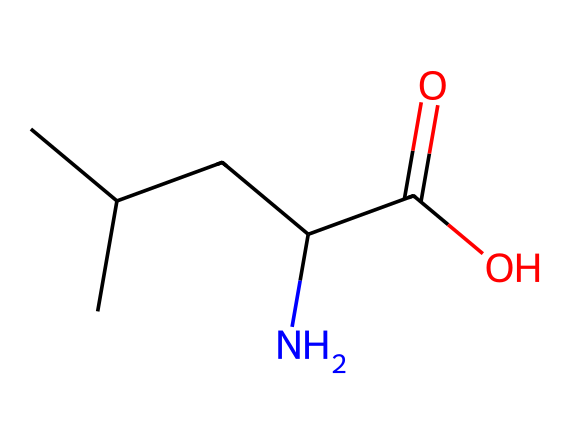What is the name of this chemical? The provided SMILES represents a chemical with the basic structure resembling an amino acid, specifically showing a carboxylic acid functional group and an amine group. This aligns with the characteristics of the amino acid "valine."
Answer: valine How many carbon atoms are present in this molecule? By analyzing the SMILES representation, we can count the number of carbon atoms (C): there are four carbon atoms in the branched structure plus one in the carboxylic group, totaling five carbon atoms.
Answer: five What type of functional groups are present in this chemical? The structure shows both a carboxylic acid (-COOH) functional group and an amine (-NH2) functional group that are characteristic of amino acids. These groups play a vital role in the chemical behavior of the molecule.
Answer: carboxylic acid and amine What is the molecular formula for this chemical? To derive the molecular formula, we consider the counted atoms: 5 carbon, 11 hydrogen, 1 nitrogen, and 2 oxygen atoms, leading to the molecular formula C5H11NO2.
Answer: C5H11NO2 How does this chemical relate to insulin production? This chemical structure is indicative of amino acids, which are the building blocks of proteins, including insulin. Insulin is a peptide hormone composed of amino acids linked by peptide bonds, thus relating to the importance of amino acids in its production.
Answer: building blocks of proteins What role does the amine group play in this molecule? The amine group (-NH2) is essential because it acts as a site for amino acids to bond together in peptide formation, which is crucial in the synthesis of proteins like insulin. This functional group significantly contributes to the chemical reactivity and properties of the amino acid.
Answer: bonding site for peptides 